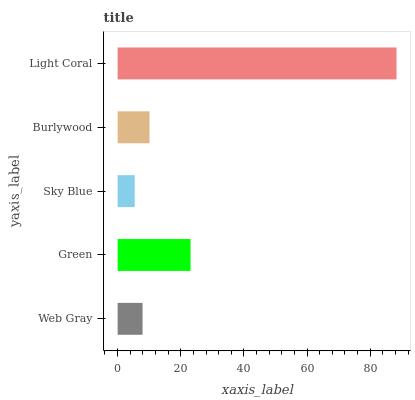Is Sky Blue the minimum?
Answer yes or no. Yes. Is Light Coral the maximum?
Answer yes or no. Yes. Is Green the minimum?
Answer yes or no. No. Is Green the maximum?
Answer yes or no. No. Is Green greater than Web Gray?
Answer yes or no. Yes. Is Web Gray less than Green?
Answer yes or no. Yes. Is Web Gray greater than Green?
Answer yes or no. No. Is Green less than Web Gray?
Answer yes or no. No. Is Burlywood the high median?
Answer yes or no. Yes. Is Burlywood the low median?
Answer yes or no. Yes. Is Green the high median?
Answer yes or no. No. Is Green the low median?
Answer yes or no. No. 